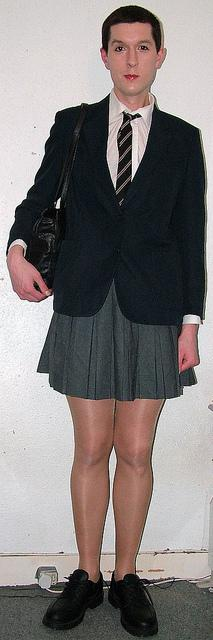What kind of uniform is worn by the man in this picture? school uniform 